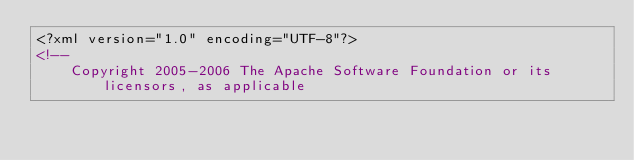<code> <loc_0><loc_0><loc_500><loc_500><_XML_><?xml version="1.0" encoding="UTF-8"?>
<!--
    Copyright 2005-2006 The Apache Software Foundation or its licensors, as applicable
</code> 